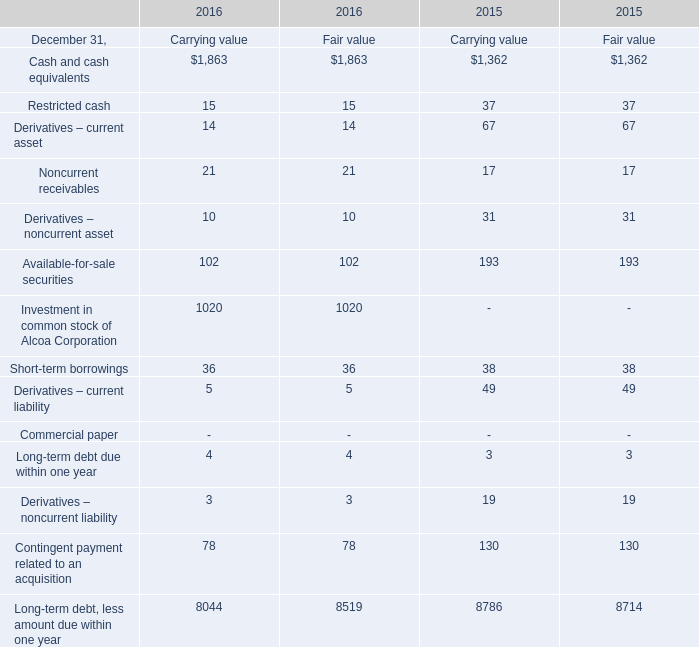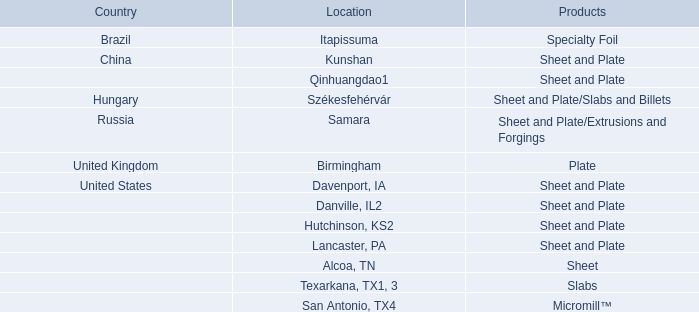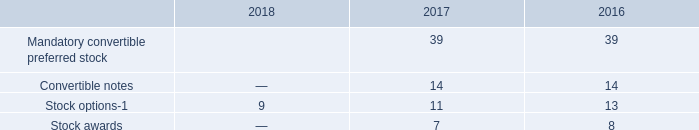What was the average of the Derivatives – noncurrent asset for Carrying value in the years where Derivatives – current asset is positive for Carrying value? 
Computations: ((10 + 31) / 2)
Answer: 20.5. 